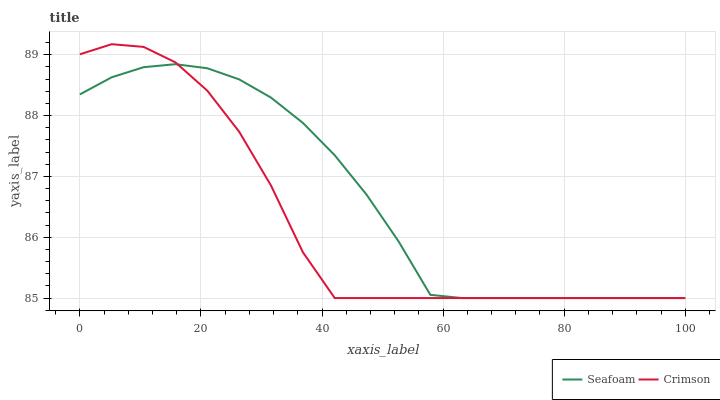Does Crimson have the minimum area under the curve?
Answer yes or no. Yes. Does Seafoam have the maximum area under the curve?
Answer yes or no. Yes. Does Seafoam have the minimum area under the curve?
Answer yes or no. No. Is Seafoam the smoothest?
Answer yes or no. Yes. Is Crimson the roughest?
Answer yes or no. Yes. Is Seafoam the roughest?
Answer yes or no. No. Does Crimson have the lowest value?
Answer yes or no. Yes. Does Crimson have the highest value?
Answer yes or no. Yes. Does Seafoam have the highest value?
Answer yes or no. No. Does Crimson intersect Seafoam?
Answer yes or no. Yes. Is Crimson less than Seafoam?
Answer yes or no. No. Is Crimson greater than Seafoam?
Answer yes or no. No. 